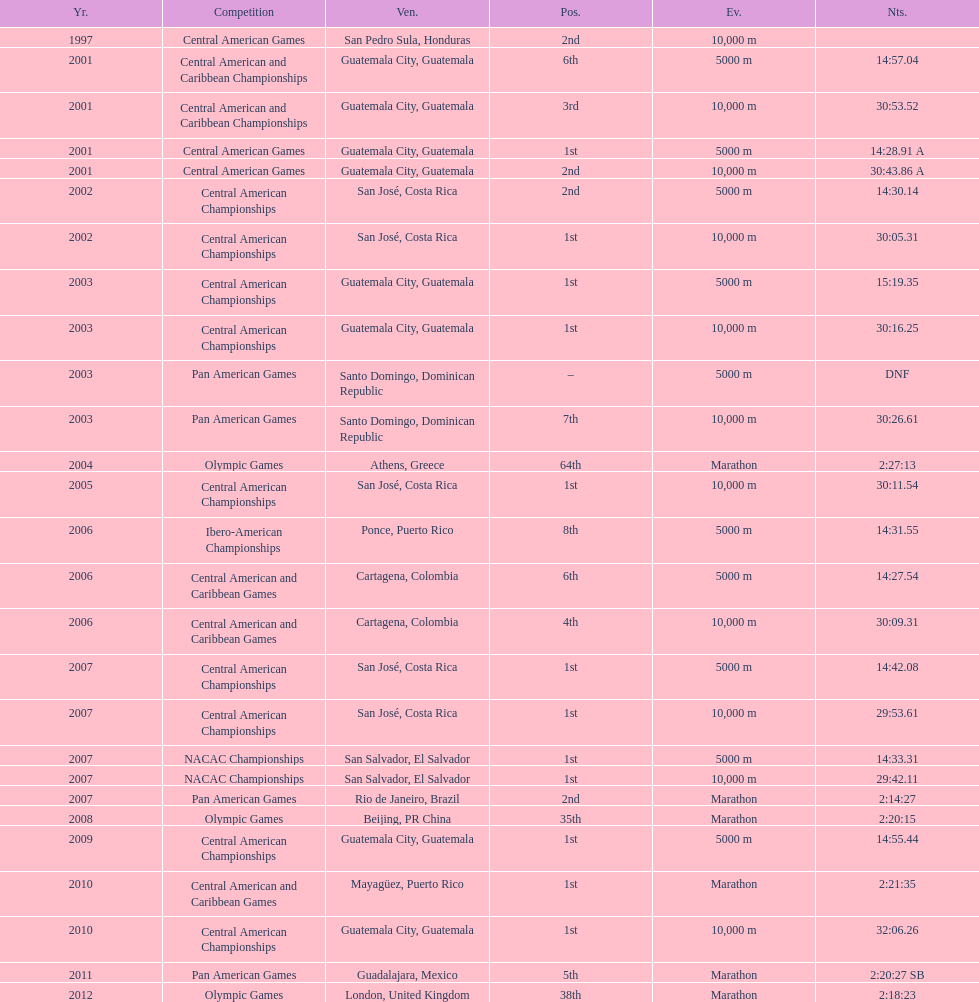What was the last competition in which a position of "2nd" was achieved? Pan American Games. 